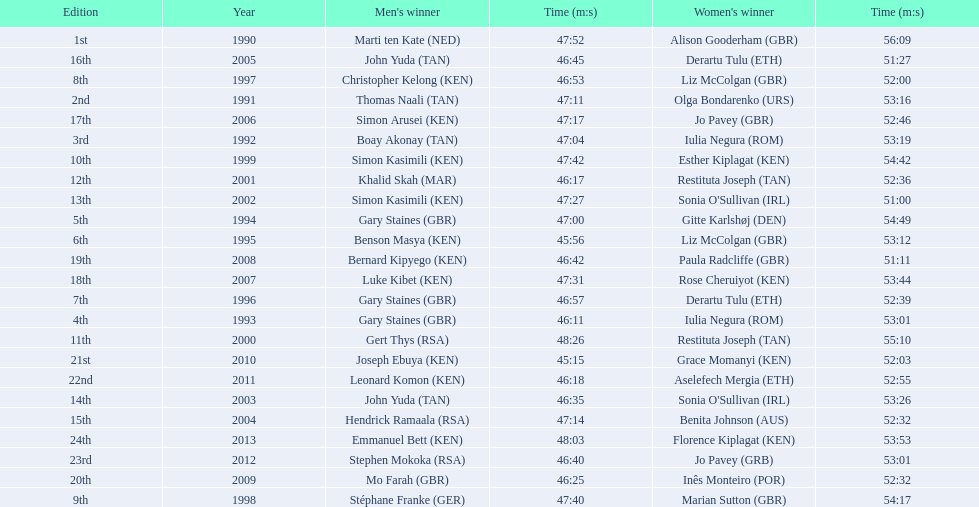Which runners are from kenya? (ken) Benson Masya (KEN), Christopher Kelong (KEN), Simon Kasimili (KEN), Simon Kasimili (KEN), Simon Arusei (KEN), Luke Kibet (KEN), Bernard Kipyego (KEN), Joseph Ebuya (KEN), Leonard Komon (KEN), Emmanuel Bett (KEN). Of these, which times are under 46 minutes? Benson Masya (KEN), Joseph Ebuya (KEN). Which of these runners had the faster time? Joseph Ebuya (KEN). 